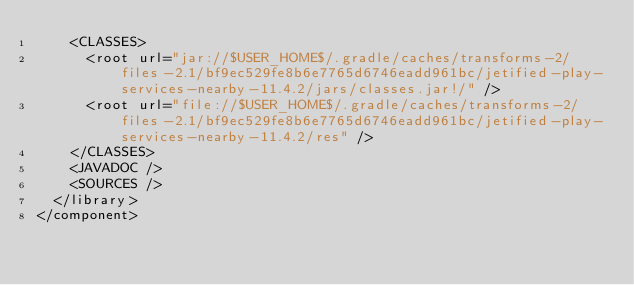<code> <loc_0><loc_0><loc_500><loc_500><_XML_>    <CLASSES>
      <root url="jar://$USER_HOME$/.gradle/caches/transforms-2/files-2.1/bf9ec529fe8b6e7765d6746eadd961bc/jetified-play-services-nearby-11.4.2/jars/classes.jar!/" />
      <root url="file://$USER_HOME$/.gradle/caches/transforms-2/files-2.1/bf9ec529fe8b6e7765d6746eadd961bc/jetified-play-services-nearby-11.4.2/res" />
    </CLASSES>
    <JAVADOC />
    <SOURCES />
  </library>
</component></code> 